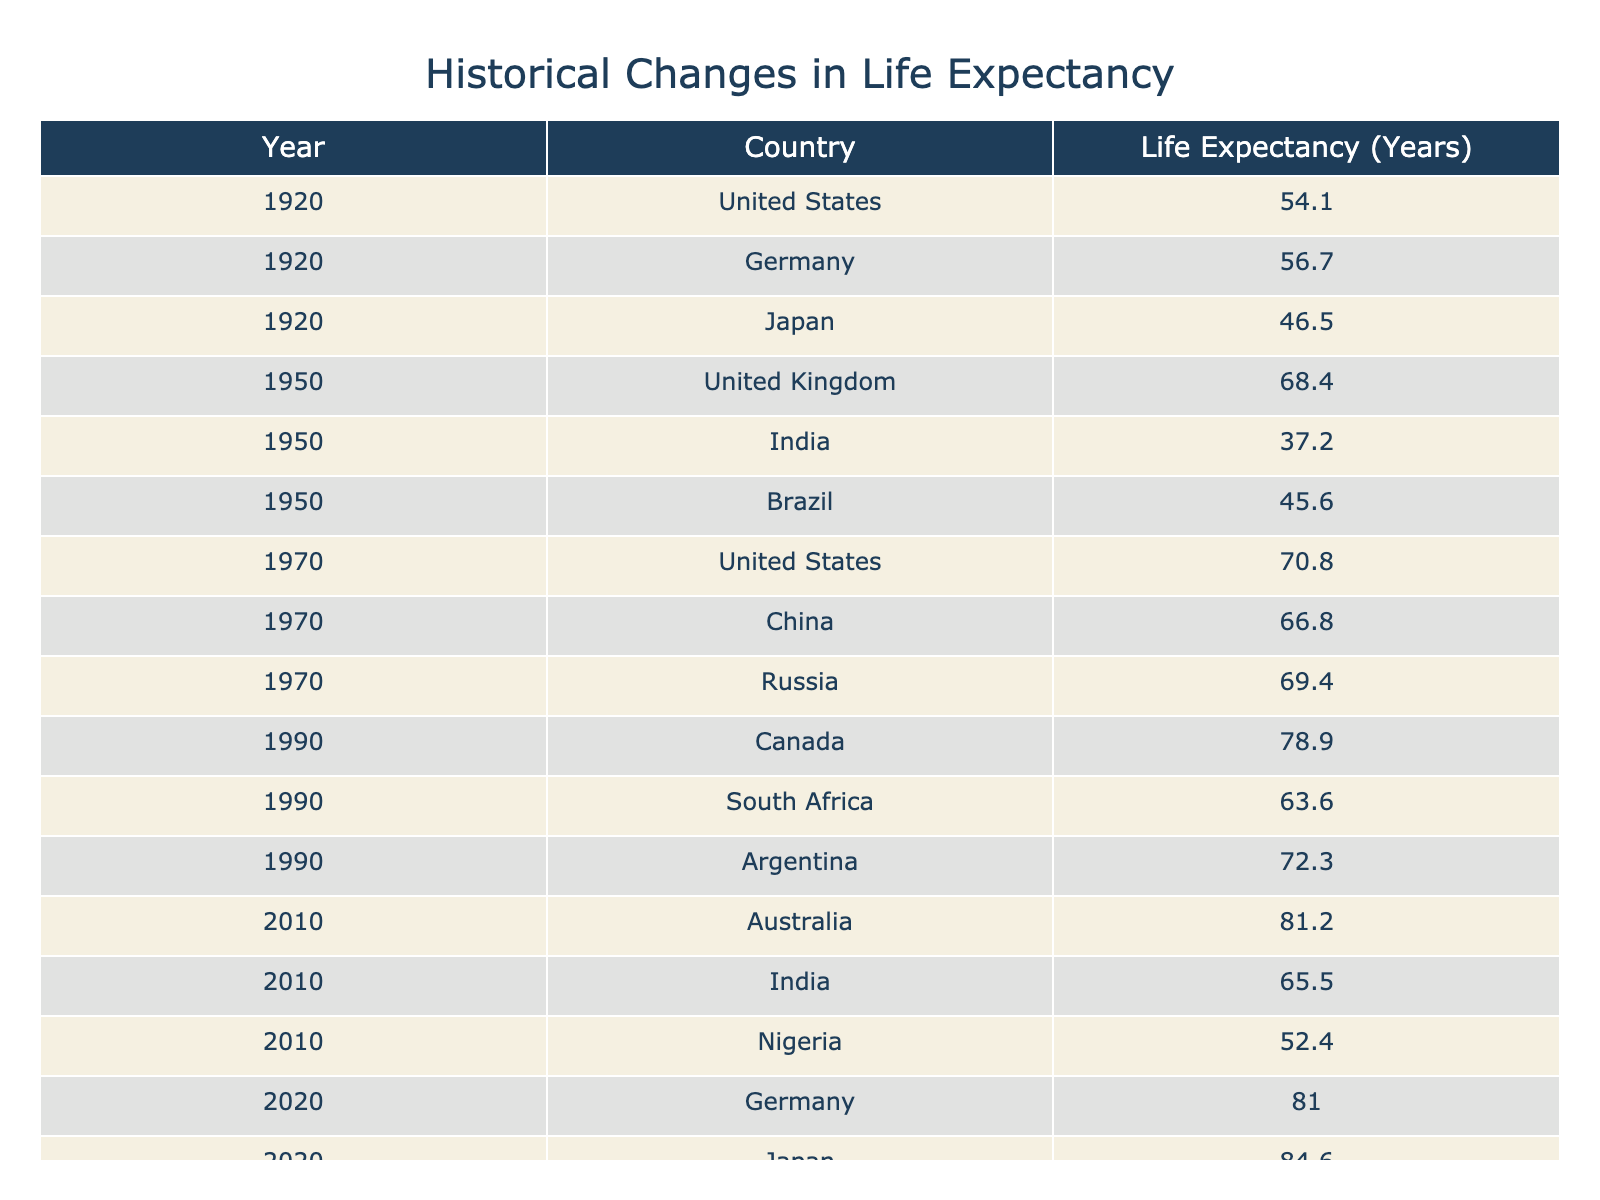What was the life expectancy in Japan in 1920? The table shows the specific life expectancy for each country in various years. For Japan, the life expectancy in 1920 is listed as 46.5 years.
Answer: 46.5 What country had the highest life expectancy in 2010? In 2010, the table lists life expectancy for several countries, with Australia having the highest value at 81.2 years.
Answer: Australia Is life expectancy in the United States greater in 2020 compared to 1950? In the table, the life expectancy in the United States in 2020 is 78.8 years, while in 1950 it was 68.4 years. Since 78.8 > 68.4, the statement is true.
Answer: Yes What is the difference in life expectancy between Germany in 2020 and Japan in 2020? The table shows that Germany had a life expectancy of 81.0 years in 2020, while Japan had 84.6 years. The difference is calculated as 84.6 - 81.0 = 3.6 years.
Answer: 3.6 years Which country improved its life expectancy the most from 1950 to 2010? From the table, India had a life expectancy of 37.2 years in 1950 and improved to 65.5 years in 2010, with an increase of 65.5 - 37.2 = 28.3 years. This is the largest improvement compared to the other countries listed.
Answer: India 